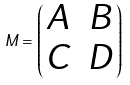Convert formula to latex. <formula><loc_0><loc_0><loc_500><loc_500>M = \left ( \begin{matrix} A & B \\ C & D \\ \end{matrix} \right )</formula> 